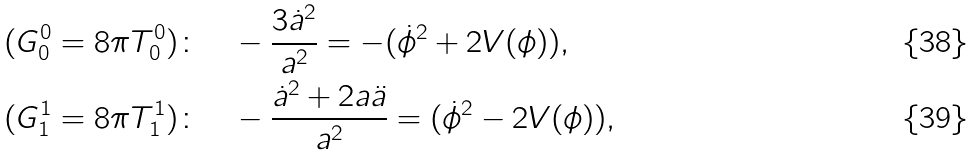<formula> <loc_0><loc_0><loc_500><loc_500>& ( G ^ { 0 } _ { 0 } = 8 \pi T ^ { 0 } _ { 0 } ) \colon \quad - \frac { 3 \dot { a } ^ { 2 } } { a ^ { 2 } } = - ( \dot { \phi } ^ { 2 } + 2 V ( \phi ) ) , \\ & ( G ^ { 1 } _ { 1 } = 8 \pi T ^ { 1 } _ { 1 } ) \colon \quad - \frac { \dot { a } ^ { 2 } + 2 a \ddot { a } } { a ^ { 2 } } = ( \dot { \phi } ^ { 2 } - 2 V ( \phi ) ) ,</formula> 